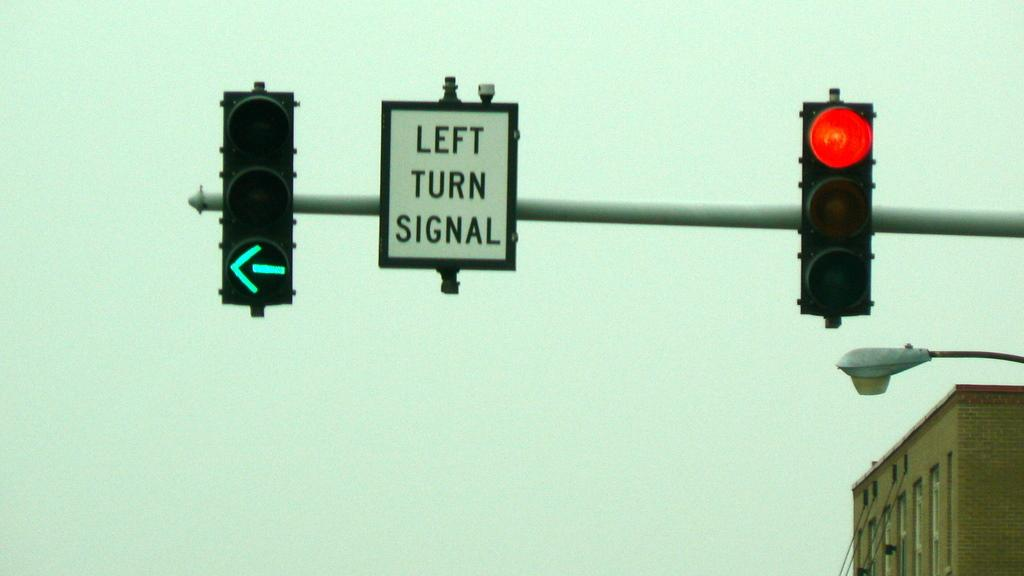Provide a one-sentence caption for the provided image. A traffic light with a green arrow is lit up next to a left turn signal sign. 